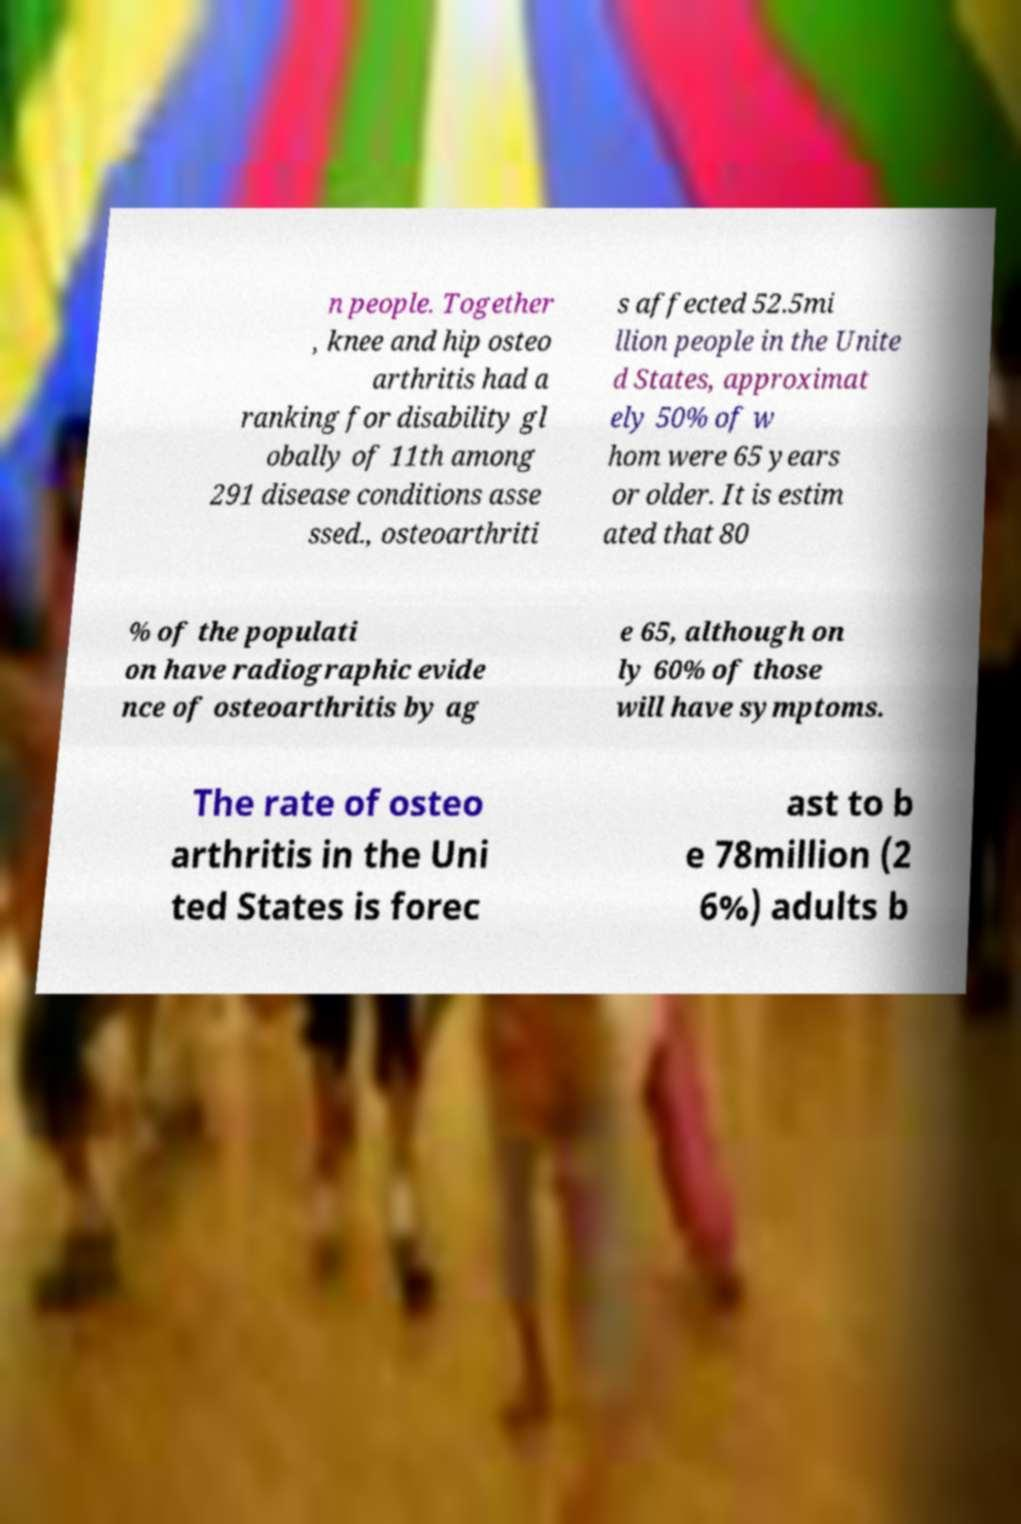Please identify and transcribe the text found in this image. n people. Together , knee and hip osteo arthritis had a ranking for disability gl obally of 11th among 291 disease conditions asse ssed., osteoarthriti s affected 52.5mi llion people in the Unite d States, approximat ely 50% of w hom were 65 years or older. It is estim ated that 80 % of the populati on have radiographic evide nce of osteoarthritis by ag e 65, although on ly 60% of those will have symptoms. The rate of osteo arthritis in the Uni ted States is forec ast to b e 78million (2 6%) adults b 